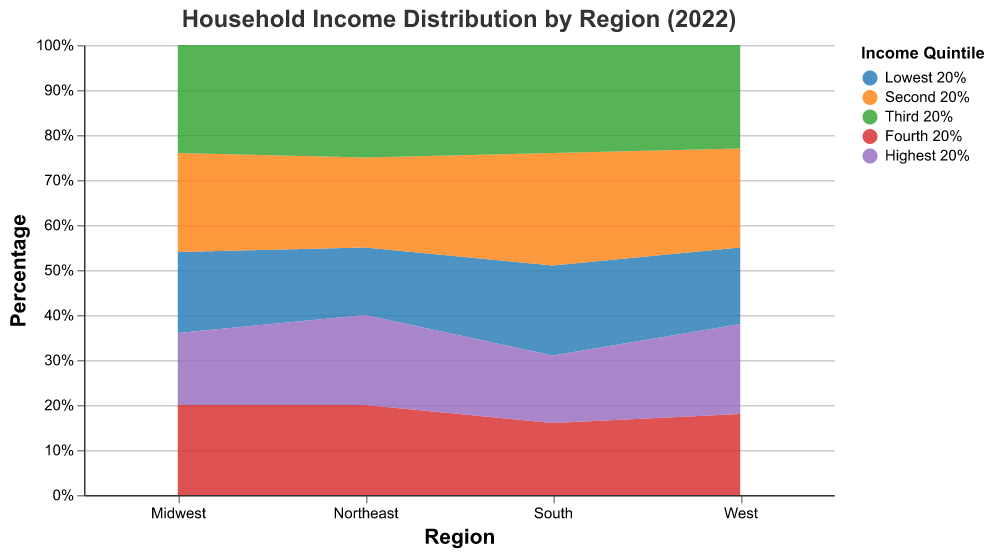What's the title of the figure? The title of the figure is usually displayed at the top and serves to inform viewers about the content of the chart. In this case, the title is clearly given.
Answer: Household Income Distribution by Region (2022) Which income quintile has the highest percentage in the Northeast region? To determine this, look at the area size corresponding to each income quintile color for the Northeast region. The third 20% has the largest area.
Answer: Third 20% How does the percentage of the lowest 20% income quintile in the Midwest compare to the South? Compare the height of the color section representing the lowest 20% in the Midwest and South regions. The Midwest has 18% whereas the South has 20%.
Answer: The Midwest has a lower percentage than the South Which region shows the highest percentage for the second 20% income quintile? Look for the region with the largest area covered by the color representing the second 20% income quintile. The South has the highest percentage at 25%.
Answer: South What's the combined percentage of the top two income quintiles (Fourth 20% and Highest 20%) in the West region? Identify the percentages for the fourth 20% and highest 20% in the West. Add these percentages: 18% (Fourth 20%) + 20% (Highest 20%).
Answer: 38% Which region has the smallest percentage for the highest 20% income quintile? Examine the sections of the highest 20% income quintile across all regions and find the smallest area. The South has the smallest at 15%.
Answer: South Which income quintile is most uniform across all regions? Assess the consistency in the area sizes of each income quintile across regions. The third 20% quintile is most uniform.
Answer: Third 20% How does the South region's percentage for the fourth 20% quintile compare to the Northeast's? Compare the areas representing the fourth 20% income quintile between the South (16%) and Northeast (20%).
Answer: The South has a lower percentage than the Northeast What’s the average percentage of the lowest 20% income quintile across all regions? Calculate the average by adding the percentages for the lowest 20% from all regions and dividing by the number of regions: (15 + 18 + 20 + 17) / 4 = 17.5%.
Answer: 17.5% What's the sum of the percentages for the second 20% and third 20% income quintiles in the Midwest? Sum the percentages of the second 20% (22%) and third 20% (24%) income quintiles in the Midwest: 22 + 24 = 46%.
Answer: 46% 